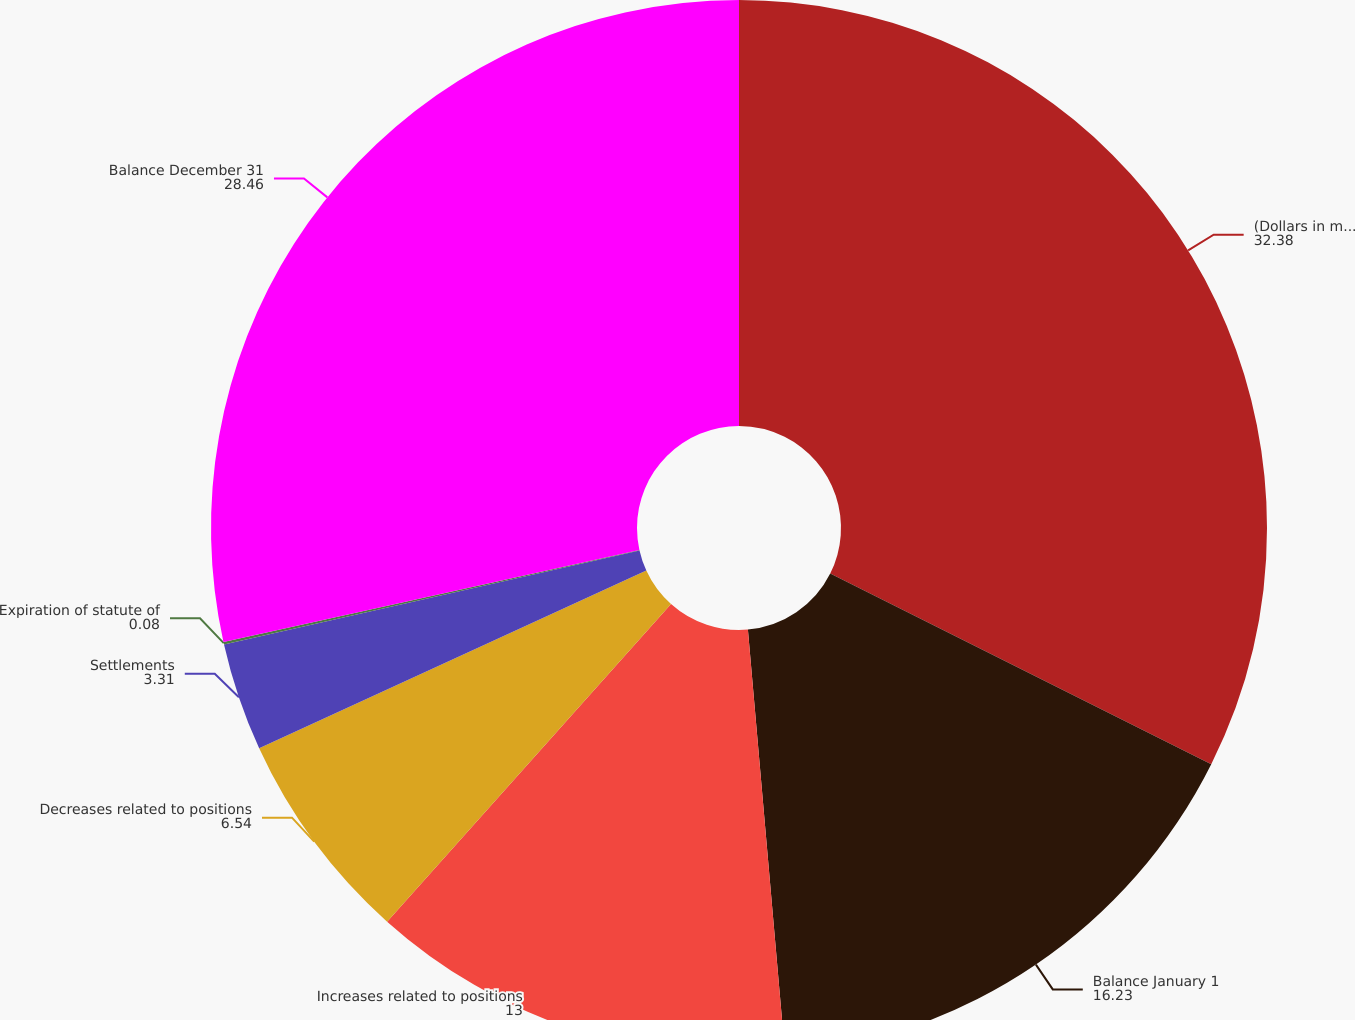<chart> <loc_0><loc_0><loc_500><loc_500><pie_chart><fcel>(Dollars in millions)<fcel>Balance January 1<fcel>Increases related to positions<fcel>Decreases related to positions<fcel>Settlements<fcel>Expiration of statute of<fcel>Balance December 31<nl><fcel>32.38%<fcel>16.23%<fcel>13.0%<fcel>6.54%<fcel>3.31%<fcel>0.08%<fcel>28.46%<nl></chart> 